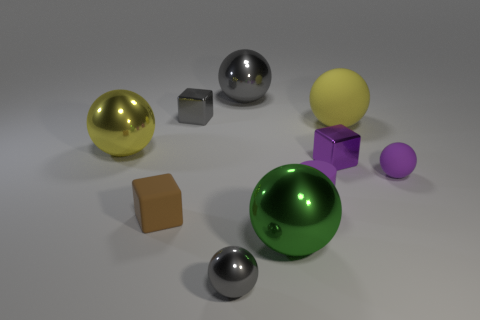Subtract all yellow spheres. How many spheres are left? 4 Subtract all tiny gray metallic spheres. How many spheres are left? 5 Subtract 3 balls. How many balls are left? 3 Subtract all purple balls. Subtract all green cylinders. How many balls are left? 5 Subtract all blocks. How many objects are left? 7 Add 9 green shiny cylinders. How many green shiny cylinders exist? 9 Subtract 0 green cylinders. How many objects are left? 10 Subtract all small brown things. Subtract all big yellow metallic balls. How many objects are left? 8 Add 5 shiny cubes. How many shiny cubes are left? 7 